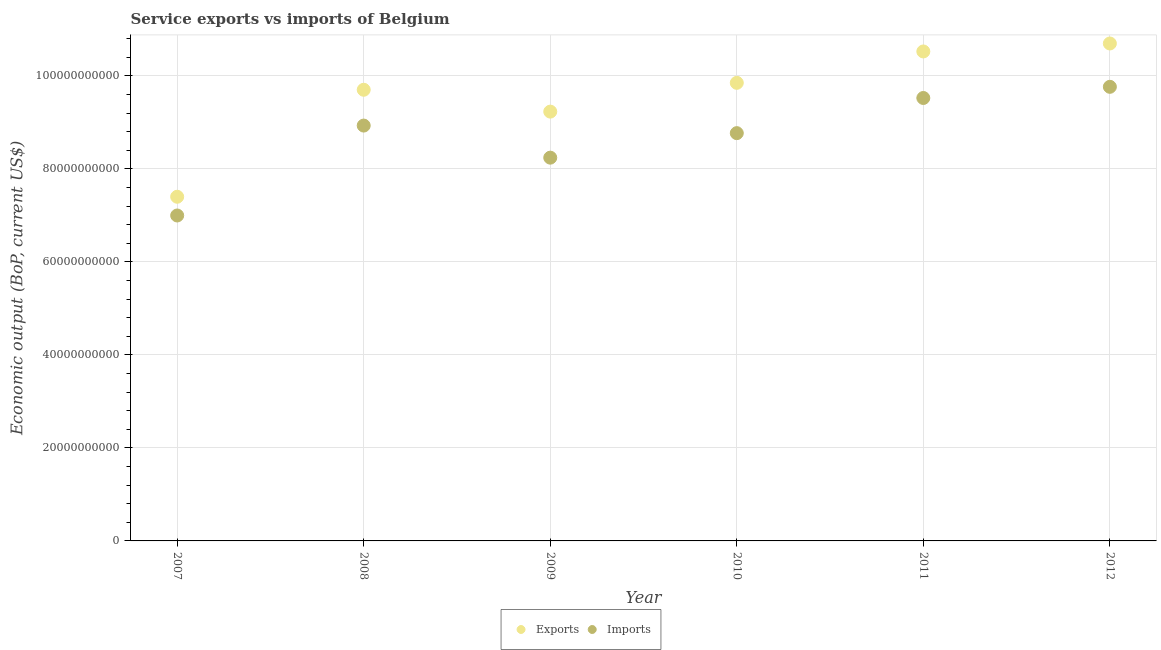Is the number of dotlines equal to the number of legend labels?
Your answer should be compact. Yes. What is the amount of service imports in 2009?
Provide a short and direct response. 8.24e+1. Across all years, what is the maximum amount of service imports?
Give a very brief answer. 9.76e+1. Across all years, what is the minimum amount of service imports?
Your answer should be very brief. 7.00e+1. In which year was the amount of service exports maximum?
Ensure brevity in your answer.  2012. In which year was the amount of service imports minimum?
Your answer should be very brief. 2007. What is the total amount of service exports in the graph?
Give a very brief answer. 5.74e+11. What is the difference between the amount of service imports in 2007 and that in 2010?
Keep it short and to the point. -1.77e+1. What is the difference between the amount of service exports in 2010 and the amount of service imports in 2012?
Ensure brevity in your answer.  8.56e+08. What is the average amount of service exports per year?
Offer a very short reply. 9.57e+1. In the year 2009, what is the difference between the amount of service imports and amount of service exports?
Provide a short and direct response. -9.90e+09. In how many years, is the amount of service exports greater than 100000000000 US$?
Make the answer very short. 2. What is the ratio of the amount of service exports in 2010 to that in 2011?
Provide a succinct answer. 0.94. What is the difference between the highest and the second highest amount of service imports?
Give a very brief answer. 2.40e+09. What is the difference between the highest and the lowest amount of service exports?
Ensure brevity in your answer.  3.30e+1. Does the amount of service exports monotonically increase over the years?
Provide a short and direct response. No. Is the amount of service imports strictly less than the amount of service exports over the years?
Keep it short and to the point. Yes. Are the values on the major ticks of Y-axis written in scientific E-notation?
Offer a very short reply. No. Does the graph contain any zero values?
Offer a very short reply. No. Does the graph contain grids?
Provide a short and direct response. Yes. Where does the legend appear in the graph?
Make the answer very short. Bottom center. How are the legend labels stacked?
Offer a terse response. Horizontal. What is the title of the graph?
Offer a very short reply. Service exports vs imports of Belgium. Does "Residents" appear as one of the legend labels in the graph?
Offer a terse response. No. What is the label or title of the X-axis?
Offer a very short reply. Year. What is the label or title of the Y-axis?
Make the answer very short. Economic output (BoP, current US$). What is the Economic output (BoP, current US$) of Exports in 2007?
Give a very brief answer. 7.40e+1. What is the Economic output (BoP, current US$) of Imports in 2007?
Make the answer very short. 7.00e+1. What is the Economic output (BoP, current US$) in Exports in 2008?
Ensure brevity in your answer.  9.70e+1. What is the Economic output (BoP, current US$) of Imports in 2008?
Give a very brief answer. 8.93e+1. What is the Economic output (BoP, current US$) in Exports in 2009?
Your response must be concise. 9.23e+1. What is the Economic output (BoP, current US$) of Imports in 2009?
Your answer should be very brief. 8.24e+1. What is the Economic output (BoP, current US$) in Exports in 2010?
Offer a terse response. 9.85e+1. What is the Economic output (BoP, current US$) in Imports in 2010?
Give a very brief answer. 8.77e+1. What is the Economic output (BoP, current US$) of Exports in 2011?
Your answer should be compact. 1.05e+11. What is the Economic output (BoP, current US$) of Imports in 2011?
Keep it short and to the point. 9.52e+1. What is the Economic output (BoP, current US$) of Exports in 2012?
Provide a succinct answer. 1.07e+11. What is the Economic output (BoP, current US$) in Imports in 2012?
Your answer should be compact. 9.76e+1. Across all years, what is the maximum Economic output (BoP, current US$) in Exports?
Keep it short and to the point. 1.07e+11. Across all years, what is the maximum Economic output (BoP, current US$) in Imports?
Provide a succinct answer. 9.76e+1. Across all years, what is the minimum Economic output (BoP, current US$) in Exports?
Offer a very short reply. 7.40e+1. Across all years, what is the minimum Economic output (BoP, current US$) in Imports?
Offer a very short reply. 7.00e+1. What is the total Economic output (BoP, current US$) of Exports in the graph?
Your response must be concise. 5.74e+11. What is the total Economic output (BoP, current US$) in Imports in the graph?
Your response must be concise. 5.22e+11. What is the difference between the Economic output (BoP, current US$) in Exports in 2007 and that in 2008?
Your answer should be compact. -2.30e+1. What is the difference between the Economic output (BoP, current US$) in Imports in 2007 and that in 2008?
Your answer should be very brief. -1.93e+1. What is the difference between the Economic output (BoP, current US$) of Exports in 2007 and that in 2009?
Provide a succinct answer. -1.83e+1. What is the difference between the Economic output (BoP, current US$) of Imports in 2007 and that in 2009?
Your answer should be compact. -1.24e+1. What is the difference between the Economic output (BoP, current US$) of Exports in 2007 and that in 2010?
Offer a very short reply. -2.45e+1. What is the difference between the Economic output (BoP, current US$) in Imports in 2007 and that in 2010?
Your answer should be compact. -1.77e+1. What is the difference between the Economic output (BoP, current US$) in Exports in 2007 and that in 2011?
Make the answer very short. -3.12e+1. What is the difference between the Economic output (BoP, current US$) in Imports in 2007 and that in 2011?
Ensure brevity in your answer.  -2.53e+1. What is the difference between the Economic output (BoP, current US$) of Exports in 2007 and that in 2012?
Offer a terse response. -3.30e+1. What is the difference between the Economic output (BoP, current US$) of Imports in 2007 and that in 2012?
Provide a succinct answer. -2.77e+1. What is the difference between the Economic output (BoP, current US$) in Exports in 2008 and that in 2009?
Provide a short and direct response. 4.70e+09. What is the difference between the Economic output (BoP, current US$) in Imports in 2008 and that in 2009?
Offer a very short reply. 6.90e+09. What is the difference between the Economic output (BoP, current US$) of Exports in 2008 and that in 2010?
Provide a succinct answer. -1.49e+09. What is the difference between the Economic output (BoP, current US$) of Imports in 2008 and that in 2010?
Offer a terse response. 1.63e+09. What is the difference between the Economic output (BoP, current US$) of Exports in 2008 and that in 2011?
Offer a terse response. -8.23e+09. What is the difference between the Economic output (BoP, current US$) of Imports in 2008 and that in 2011?
Make the answer very short. -5.93e+09. What is the difference between the Economic output (BoP, current US$) in Exports in 2008 and that in 2012?
Ensure brevity in your answer.  -9.95e+09. What is the difference between the Economic output (BoP, current US$) of Imports in 2008 and that in 2012?
Offer a very short reply. -8.33e+09. What is the difference between the Economic output (BoP, current US$) of Exports in 2009 and that in 2010?
Your answer should be very brief. -6.19e+09. What is the difference between the Economic output (BoP, current US$) of Imports in 2009 and that in 2010?
Your answer should be very brief. -5.27e+09. What is the difference between the Economic output (BoP, current US$) in Exports in 2009 and that in 2011?
Give a very brief answer. -1.29e+1. What is the difference between the Economic output (BoP, current US$) of Imports in 2009 and that in 2011?
Your answer should be very brief. -1.28e+1. What is the difference between the Economic output (BoP, current US$) in Exports in 2009 and that in 2012?
Provide a succinct answer. -1.47e+1. What is the difference between the Economic output (BoP, current US$) in Imports in 2009 and that in 2012?
Your answer should be very brief. -1.52e+1. What is the difference between the Economic output (BoP, current US$) in Exports in 2010 and that in 2011?
Give a very brief answer. -6.75e+09. What is the difference between the Economic output (BoP, current US$) in Imports in 2010 and that in 2011?
Your answer should be compact. -7.56e+09. What is the difference between the Economic output (BoP, current US$) in Exports in 2010 and that in 2012?
Your response must be concise. -8.46e+09. What is the difference between the Economic output (BoP, current US$) of Imports in 2010 and that in 2012?
Make the answer very short. -9.96e+09. What is the difference between the Economic output (BoP, current US$) of Exports in 2011 and that in 2012?
Provide a succinct answer. -1.72e+09. What is the difference between the Economic output (BoP, current US$) of Imports in 2011 and that in 2012?
Ensure brevity in your answer.  -2.40e+09. What is the difference between the Economic output (BoP, current US$) of Exports in 2007 and the Economic output (BoP, current US$) of Imports in 2008?
Provide a succinct answer. -1.53e+1. What is the difference between the Economic output (BoP, current US$) in Exports in 2007 and the Economic output (BoP, current US$) in Imports in 2009?
Your answer should be compact. -8.41e+09. What is the difference between the Economic output (BoP, current US$) in Exports in 2007 and the Economic output (BoP, current US$) in Imports in 2010?
Offer a very short reply. -1.37e+1. What is the difference between the Economic output (BoP, current US$) of Exports in 2007 and the Economic output (BoP, current US$) of Imports in 2011?
Provide a short and direct response. -2.12e+1. What is the difference between the Economic output (BoP, current US$) of Exports in 2007 and the Economic output (BoP, current US$) of Imports in 2012?
Make the answer very short. -2.36e+1. What is the difference between the Economic output (BoP, current US$) in Exports in 2008 and the Economic output (BoP, current US$) in Imports in 2009?
Your answer should be very brief. 1.46e+1. What is the difference between the Economic output (BoP, current US$) in Exports in 2008 and the Economic output (BoP, current US$) in Imports in 2010?
Offer a very short reply. 9.33e+09. What is the difference between the Economic output (BoP, current US$) in Exports in 2008 and the Economic output (BoP, current US$) in Imports in 2011?
Provide a succinct answer. 1.77e+09. What is the difference between the Economic output (BoP, current US$) of Exports in 2008 and the Economic output (BoP, current US$) of Imports in 2012?
Offer a very short reply. -6.33e+08. What is the difference between the Economic output (BoP, current US$) in Exports in 2009 and the Economic output (BoP, current US$) in Imports in 2010?
Offer a very short reply. 4.63e+09. What is the difference between the Economic output (BoP, current US$) of Exports in 2009 and the Economic output (BoP, current US$) of Imports in 2011?
Provide a succinct answer. -2.93e+09. What is the difference between the Economic output (BoP, current US$) of Exports in 2009 and the Economic output (BoP, current US$) of Imports in 2012?
Make the answer very short. -5.33e+09. What is the difference between the Economic output (BoP, current US$) in Exports in 2010 and the Economic output (BoP, current US$) in Imports in 2011?
Provide a short and direct response. 3.26e+09. What is the difference between the Economic output (BoP, current US$) of Exports in 2010 and the Economic output (BoP, current US$) of Imports in 2012?
Give a very brief answer. 8.56e+08. What is the difference between the Economic output (BoP, current US$) of Exports in 2011 and the Economic output (BoP, current US$) of Imports in 2012?
Your answer should be compact. 7.60e+09. What is the average Economic output (BoP, current US$) in Exports per year?
Provide a succinct answer. 9.57e+1. What is the average Economic output (BoP, current US$) of Imports per year?
Your answer should be very brief. 8.70e+1. In the year 2007, what is the difference between the Economic output (BoP, current US$) in Exports and Economic output (BoP, current US$) in Imports?
Your answer should be compact. 4.03e+09. In the year 2008, what is the difference between the Economic output (BoP, current US$) of Exports and Economic output (BoP, current US$) of Imports?
Your answer should be very brief. 7.70e+09. In the year 2009, what is the difference between the Economic output (BoP, current US$) in Exports and Economic output (BoP, current US$) in Imports?
Keep it short and to the point. 9.90e+09. In the year 2010, what is the difference between the Economic output (BoP, current US$) in Exports and Economic output (BoP, current US$) in Imports?
Your answer should be very brief. 1.08e+1. In the year 2011, what is the difference between the Economic output (BoP, current US$) of Exports and Economic output (BoP, current US$) of Imports?
Your answer should be compact. 1.00e+1. In the year 2012, what is the difference between the Economic output (BoP, current US$) in Exports and Economic output (BoP, current US$) in Imports?
Provide a short and direct response. 9.32e+09. What is the ratio of the Economic output (BoP, current US$) in Exports in 2007 to that in 2008?
Make the answer very short. 0.76. What is the ratio of the Economic output (BoP, current US$) in Imports in 2007 to that in 2008?
Keep it short and to the point. 0.78. What is the ratio of the Economic output (BoP, current US$) in Exports in 2007 to that in 2009?
Your response must be concise. 0.8. What is the ratio of the Economic output (BoP, current US$) in Imports in 2007 to that in 2009?
Provide a short and direct response. 0.85. What is the ratio of the Economic output (BoP, current US$) of Exports in 2007 to that in 2010?
Your response must be concise. 0.75. What is the ratio of the Economic output (BoP, current US$) in Imports in 2007 to that in 2010?
Give a very brief answer. 0.8. What is the ratio of the Economic output (BoP, current US$) in Exports in 2007 to that in 2011?
Make the answer very short. 0.7. What is the ratio of the Economic output (BoP, current US$) of Imports in 2007 to that in 2011?
Your answer should be compact. 0.73. What is the ratio of the Economic output (BoP, current US$) of Exports in 2007 to that in 2012?
Make the answer very short. 0.69. What is the ratio of the Economic output (BoP, current US$) in Imports in 2007 to that in 2012?
Keep it short and to the point. 0.72. What is the ratio of the Economic output (BoP, current US$) of Exports in 2008 to that in 2009?
Ensure brevity in your answer.  1.05. What is the ratio of the Economic output (BoP, current US$) in Imports in 2008 to that in 2009?
Offer a terse response. 1.08. What is the ratio of the Economic output (BoP, current US$) in Exports in 2008 to that in 2010?
Offer a terse response. 0.98. What is the ratio of the Economic output (BoP, current US$) in Imports in 2008 to that in 2010?
Your answer should be compact. 1.02. What is the ratio of the Economic output (BoP, current US$) of Exports in 2008 to that in 2011?
Give a very brief answer. 0.92. What is the ratio of the Economic output (BoP, current US$) of Imports in 2008 to that in 2011?
Your answer should be compact. 0.94. What is the ratio of the Economic output (BoP, current US$) in Exports in 2008 to that in 2012?
Give a very brief answer. 0.91. What is the ratio of the Economic output (BoP, current US$) in Imports in 2008 to that in 2012?
Keep it short and to the point. 0.91. What is the ratio of the Economic output (BoP, current US$) in Exports in 2009 to that in 2010?
Your response must be concise. 0.94. What is the ratio of the Economic output (BoP, current US$) in Imports in 2009 to that in 2010?
Give a very brief answer. 0.94. What is the ratio of the Economic output (BoP, current US$) in Exports in 2009 to that in 2011?
Your answer should be compact. 0.88. What is the ratio of the Economic output (BoP, current US$) of Imports in 2009 to that in 2011?
Keep it short and to the point. 0.87. What is the ratio of the Economic output (BoP, current US$) of Exports in 2009 to that in 2012?
Keep it short and to the point. 0.86. What is the ratio of the Economic output (BoP, current US$) of Imports in 2009 to that in 2012?
Offer a terse response. 0.84. What is the ratio of the Economic output (BoP, current US$) in Exports in 2010 to that in 2011?
Provide a short and direct response. 0.94. What is the ratio of the Economic output (BoP, current US$) of Imports in 2010 to that in 2011?
Your answer should be very brief. 0.92. What is the ratio of the Economic output (BoP, current US$) in Exports in 2010 to that in 2012?
Ensure brevity in your answer.  0.92. What is the ratio of the Economic output (BoP, current US$) of Imports in 2010 to that in 2012?
Make the answer very short. 0.9. What is the ratio of the Economic output (BoP, current US$) in Exports in 2011 to that in 2012?
Ensure brevity in your answer.  0.98. What is the ratio of the Economic output (BoP, current US$) of Imports in 2011 to that in 2012?
Your response must be concise. 0.98. What is the difference between the highest and the second highest Economic output (BoP, current US$) in Exports?
Your answer should be very brief. 1.72e+09. What is the difference between the highest and the second highest Economic output (BoP, current US$) of Imports?
Your answer should be very brief. 2.40e+09. What is the difference between the highest and the lowest Economic output (BoP, current US$) in Exports?
Your answer should be very brief. 3.30e+1. What is the difference between the highest and the lowest Economic output (BoP, current US$) of Imports?
Your answer should be compact. 2.77e+1. 